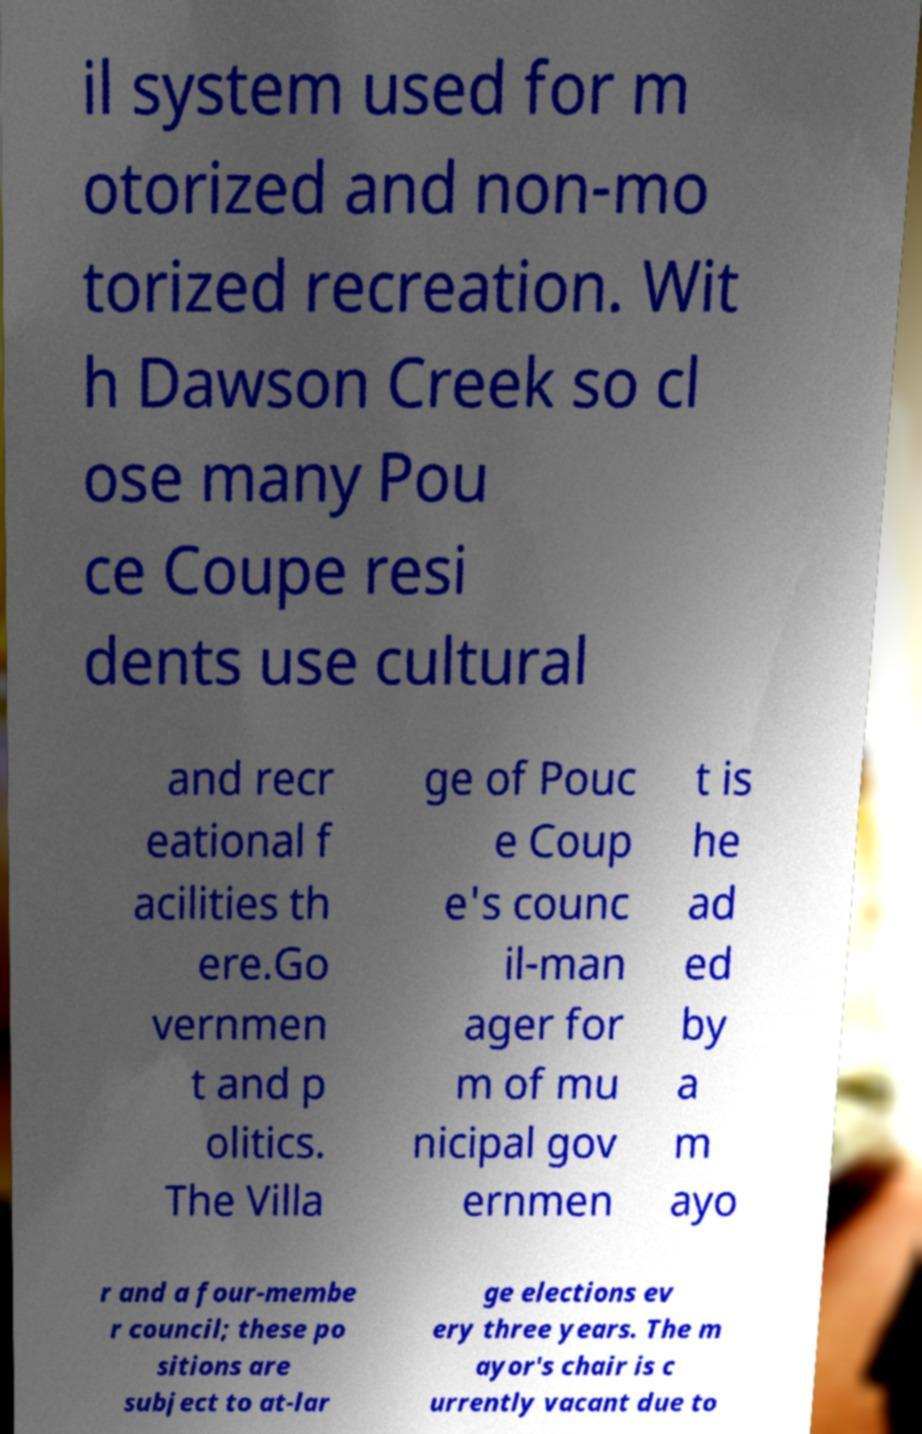For documentation purposes, I need the text within this image transcribed. Could you provide that? il system used for m otorized and non-mo torized recreation. Wit h Dawson Creek so cl ose many Pou ce Coupe resi dents use cultural and recr eational f acilities th ere.Go vernmen t and p olitics. The Villa ge of Pouc e Coup e's counc il-man ager for m of mu nicipal gov ernmen t is he ad ed by a m ayo r and a four-membe r council; these po sitions are subject to at-lar ge elections ev ery three years. The m ayor's chair is c urrently vacant due to 